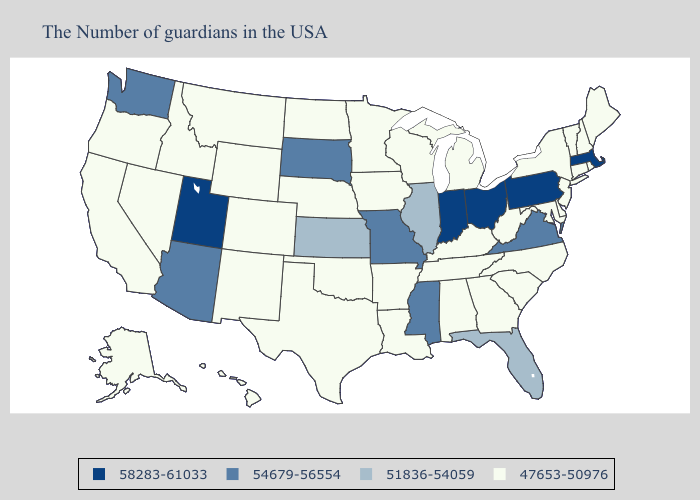Among the states that border Iowa , which have the highest value?
Keep it brief. Missouri, South Dakota. Name the states that have a value in the range 58283-61033?
Short answer required. Massachusetts, Pennsylvania, Ohio, Indiana, Utah. What is the highest value in the USA?
Short answer required. 58283-61033. What is the highest value in states that border Iowa?
Write a very short answer. 54679-56554. Does Illinois have a higher value than Georgia?
Be succinct. Yes. Name the states that have a value in the range 47653-50976?
Give a very brief answer. Maine, Rhode Island, New Hampshire, Vermont, Connecticut, New York, New Jersey, Delaware, Maryland, North Carolina, South Carolina, West Virginia, Georgia, Michigan, Kentucky, Alabama, Tennessee, Wisconsin, Louisiana, Arkansas, Minnesota, Iowa, Nebraska, Oklahoma, Texas, North Dakota, Wyoming, Colorado, New Mexico, Montana, Idaho, Nevada, California, Oregon, Alaska, Hawaii. Does Washington have the lowest value in the USA?
Quick response, please. No. What is the lowest value in the Northeast?
Write a very short answer. 47653-50976. What is the value of Florida?
Quick response, please. 51836-54059. Does the first symbol in the legend represent the smallest category?
Give a very brief answer. No. Does South Carolina have the lowest value in the South?
Quick response, please. Yes. Does Utah have the highest value in the West?
Quick response, please. Yes. What is the value of Colorado?
Be succinct. 47653-50976. Which states hav the highest value in the West?
Quick response, please. Utah. What is the value of Maine?
Concise answer only. 47653-50976. 